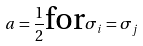<formula> <loc_0><loc_0><loc_500><loc_500>a = \frac { 1 } { 2 } \text {for} \sigma _ { i } = \sigma _ { j }</formula> 